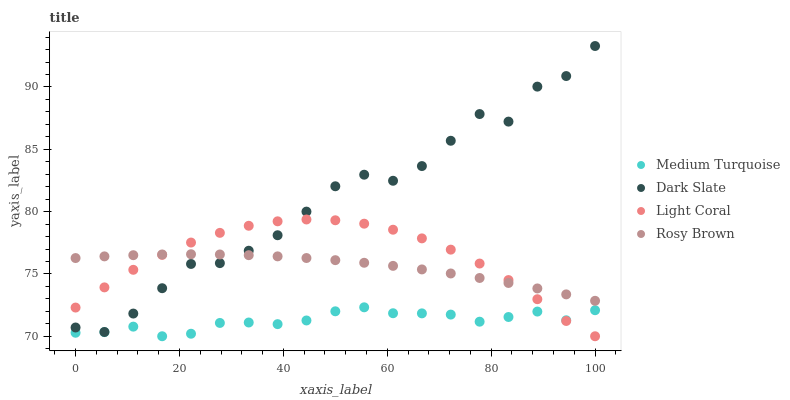Does Medium Turquoise have the minimum area under the curve?
Answer yes or no. Yes. Does Dark Slate have the maximum area under the curve?
Answer yes or no. Yes. Does Rosy Brown have the minimum area under the curve?
Answer yes or no. No. Does Rosy Brown have the maximum area under the curve?
Answer yes or no. No. Is Rosy Brown the smoothest?
Answer yes or no. Yes. Is Dark Slate the roughest?
Answer yes or no. Yes. Is Dark Slate the smoothest?
Answer yes or no. No. Is Rosy Brown the roughest?
Answer yes or no. No. Does Light Coral have the lowest value?
Answer yes or no. Yes. Does Dark Slate have the lowest value?
Answer yes or no. No. Does Dark Slate have the highest value?
Answer yes or no. Yes. Does Rosy Brown have the highest value?
Answer yes or no. No. Is Medium Turquoise less than Dark Slate?
Answer yes or no. Yes. Is Rosy Brown greater than Medium Turquoise?
Answer yes or no. Yes. Does Dark Slate intersect Light Coral?
Answer yes or no. Yes. Is Dark Slate less than Light Coral?
Answer yes or no. No. Is Dark Slate greater than Light Coral?
Answer yes or no. No. Does Medium Turquoise intersect Dark Slate?
Answer yes or no. No. 